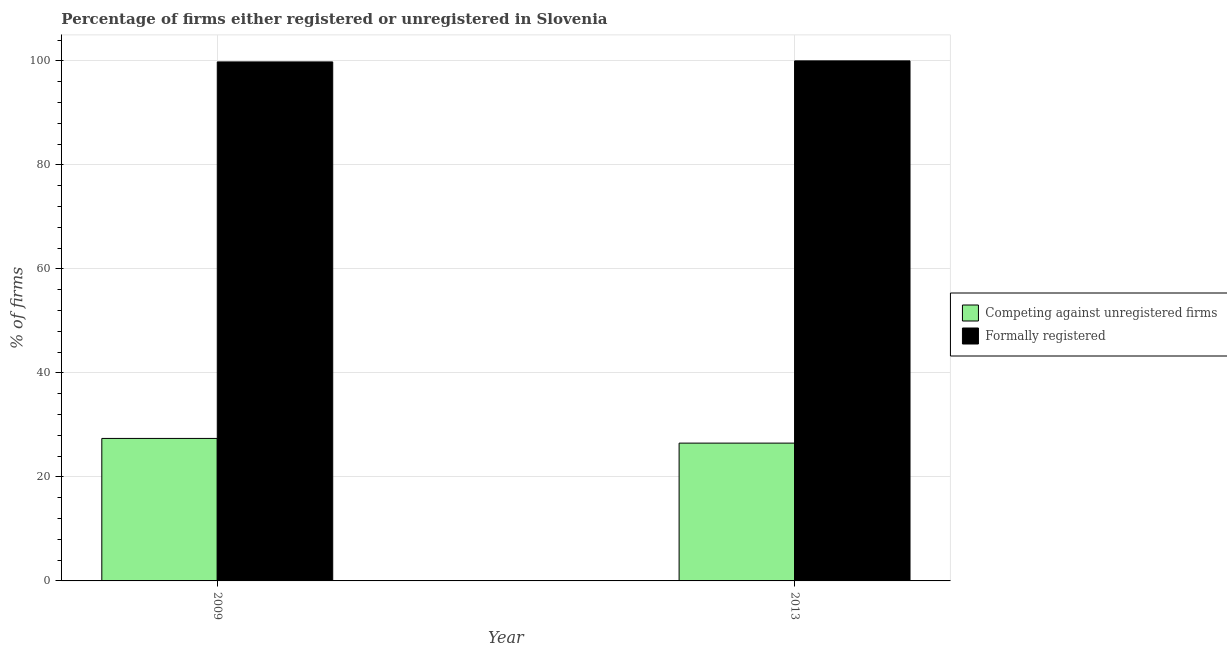How many different coloured bars are there?
Give a very brief answer. 2. How many groups of bars are there?
Your answer should be compact. 2. Are the number of bars per tick equal to the number of legend labels?
Give a very brief answer. Yes. Are the number of bars on each tick of the X-axis equal?
Your answer should be compact. Yes. How many bars are there on the 1st tick from the left?
Keep it short and to the point. 2. How many bars are there on the 1st tick from the right?
Your answer should be compact. 2. What is the label of the 1st group of bars from the left?
Your answer should be very brief. 2009. What is the percentage of registered firms in 2009?
Make the answer very short. 27.4. Across all years, what is the maximum percentage of formally registered firms?
Your response must be concise. 100. Across all years, what is the minimum percentage of formally registered firms?
Provide a succinct answer. 99.8. In which year was the percentage of registered firms maximum?
Offer a very short reply. 2009. In which year was the percentage of registered firms minimum?
Offer a terse response. 2013. What is the total percentage of registered firms in the graph?
Offer a very short reply. 53.9. What is the difference between the percentage of formally registered firms in 2009 and that in 2013?
Offer a very short reply. -0.2. What is the difference between the percentage of formally registered firms in 2009 and the percentage of registered firms in 2013?
Provide a succinct answer. -0.2. What is the average percentage of formally registered firms per year?
Give a very brief answer. 99.9. In the year 2009, what is the difference between the percentage of registered firms and percentage of formally registered firms?
Offer a terse response. 0. What does the 1st bar from the left in 2013 represents?
Your answer should be very brief. Competing against unregistered firms. What does the 1st bar from the right in 2013 represents?
Offer a very short reply. Formally registered. How many bars are there?
Make the answer very short. 4. Are all the bars in the graph horizontal?
Give a very brief answer. No. How many years are there in the graph?
Make the answer very short. 2. What is the difference between two consecutive major ticks on the Y-axis?
Keep it short and to the point. 20. Does the graph contain any zero values?
Provide a succinct answer. No. Does the graph contain grids?
Offer a terse response. Yes. How are the legend labels stacked?
Offer a terse response. Vertical. What is the title of the graph?
Ensure brevity in your answer.  Percentage of firms either registered or unregistered in Slovenia. Does "Short-term debt" appear as one of the legend labels in the graph?
Offer a terse response. No. What is the label or title of the X-axis?
Ensure brevity in your answer.  Year. What is the label or title of the Y-axis?
Offer a terse response. % of firms. What is the % of firms of Competing against unregistered firms in 2009?
Ensure brevity in your answer.  27.4. What is the % of firms in Formally registered in 2009?
Keep it short and to the point. 99.8. Across all years, what is the maximum % of firms of Competing against unregistered firms?
Your response must be concise. 27.4. Across all years, what is the minimum % of firms of Competing against unregistered firms?
Your answer should be very brief. 26.5. Across all years, what is the minimum % of firms in Formally registered?
Your answer should be very brief. 99.8. What is the total % of firms of Competing against unregistered firms in the graph?
Ensure brevity in your answer.  53.9. What is the total % of firms in Formally registered in the graph?
Make the answer very short. 199.8. What is the difference between the % of firms in Competing against unregistered firms in 2009 and that in 2013?
Your answer should be compact. 0.9. What is the difference between the % of firms of Competing against unregistered firms in 2009 and the % of firms of Formally registered in 2013?
Provide a succinct answer. -72.6. What is the average % of firms in Competing against unregistered firms per year?
Your answer should be compact. 26.95. What is the average % of firms in Formally registered per year?
Your answer should be very brief. 99.9. In the year 2009, what is the difference between the % of firms in Competing against unregistered firms and % of firms in Formally registered?
Offer a very short reply. -72.4. In the year 2013, what is the difference between the % of firms in Competing against unregistered firms and % of firms in Formally registered?
Offer a terse response. -73.5. What is the ratio of the % of firms of Competing against unregistered firms in 2009 to that in 2013?
Give a very brief answer. 1.03. What is the difference between the highest and the second highest % of firms of Competing against unregistered firms?
Offer a very short reply. 0.9. What is the difference between the highest and the second highest % of firms in Formally registered?
Your answer should be very brief. 0.2. What is the difference between the highest and the lowest % of firms of Competing against unregistered firms?
Offer a very short reply. 0.9. What is the difference between the highest and the lowest % of firms of Formally registered?
Your answer should be compact. 0.2. 